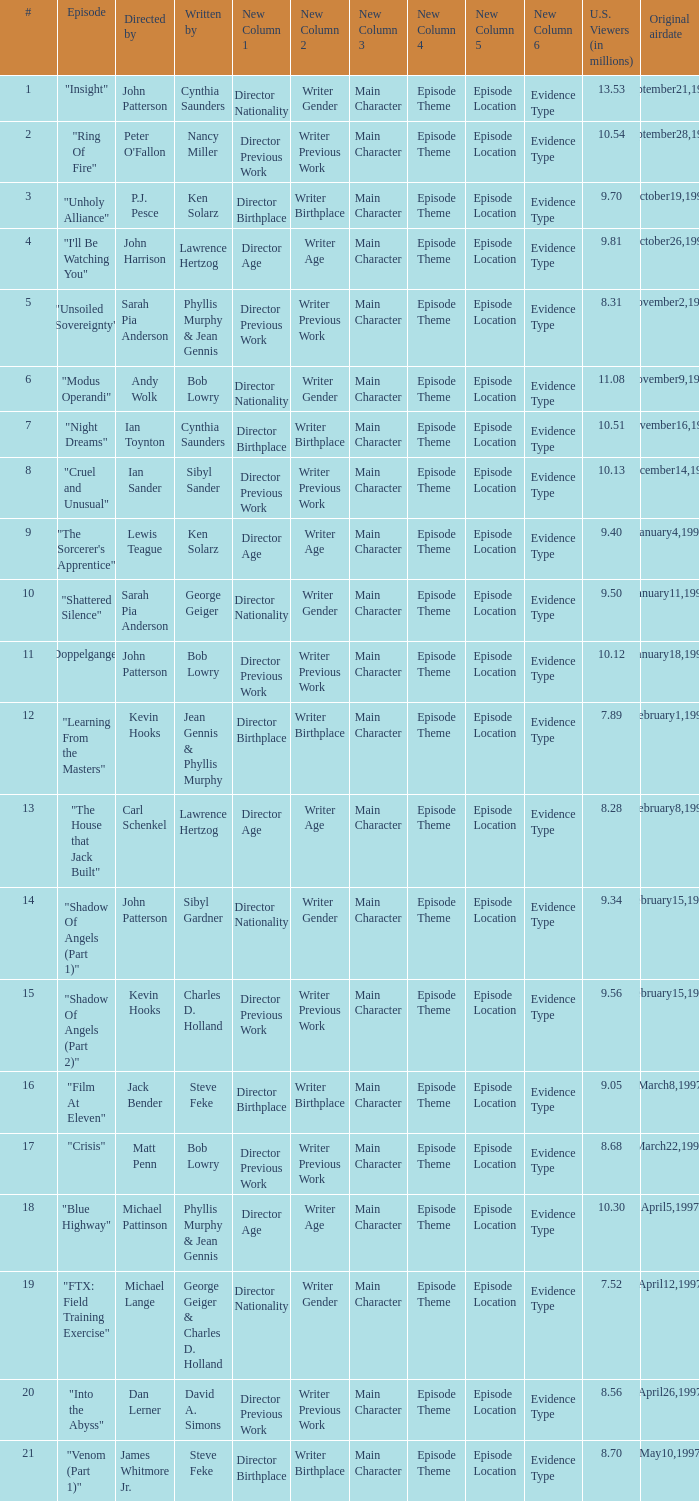What are the titles of episodes numbered 19? "FTX: Field Training Exercise". 